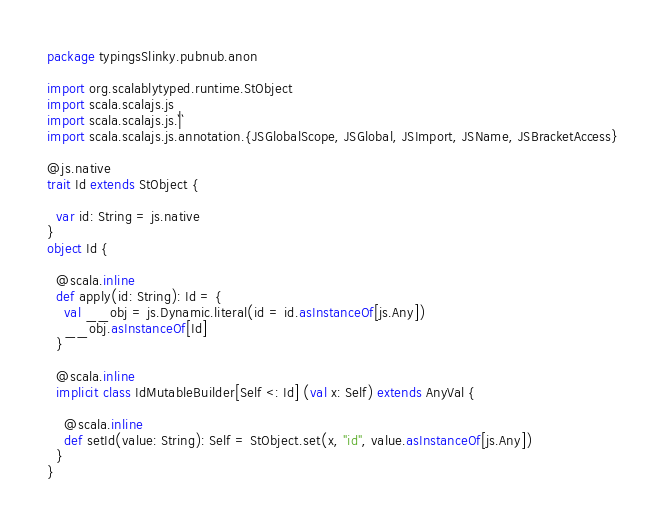<code> <loc_0><loc_0><loc_500><loc_500><_Scala_>package typingsSlinky.pubnub.anon

import org.scalablytyped.runtime.StObject
import scala.scalajs.js
import scala.scalajs.js.`|`
import scala.scalajs.js.annotation.{JSGlobalScope, JSGlobal, JSImport, JSName, JSBracketAccess}

@js.native
trait Id extends StObject {
  
  var id: String = js.native
}
object Id {
  
  @scala.inline
  def apply(id: String): Id = {
    val __obj = js.Dynamic.literal(id = id.asInstanceOf[js.Any])
    __obj.asInstanceOf[Id]
  }
  
  @scala.inline
  implicit class IdMutableBuilder[Self <: Id] (val x: Self) extends AnyVal {
    
    @scala.inline
    def setId(value: String): Self = StObject.set(x, "id", value.asInstanceOf[js.Any])
  }
}
</code> 